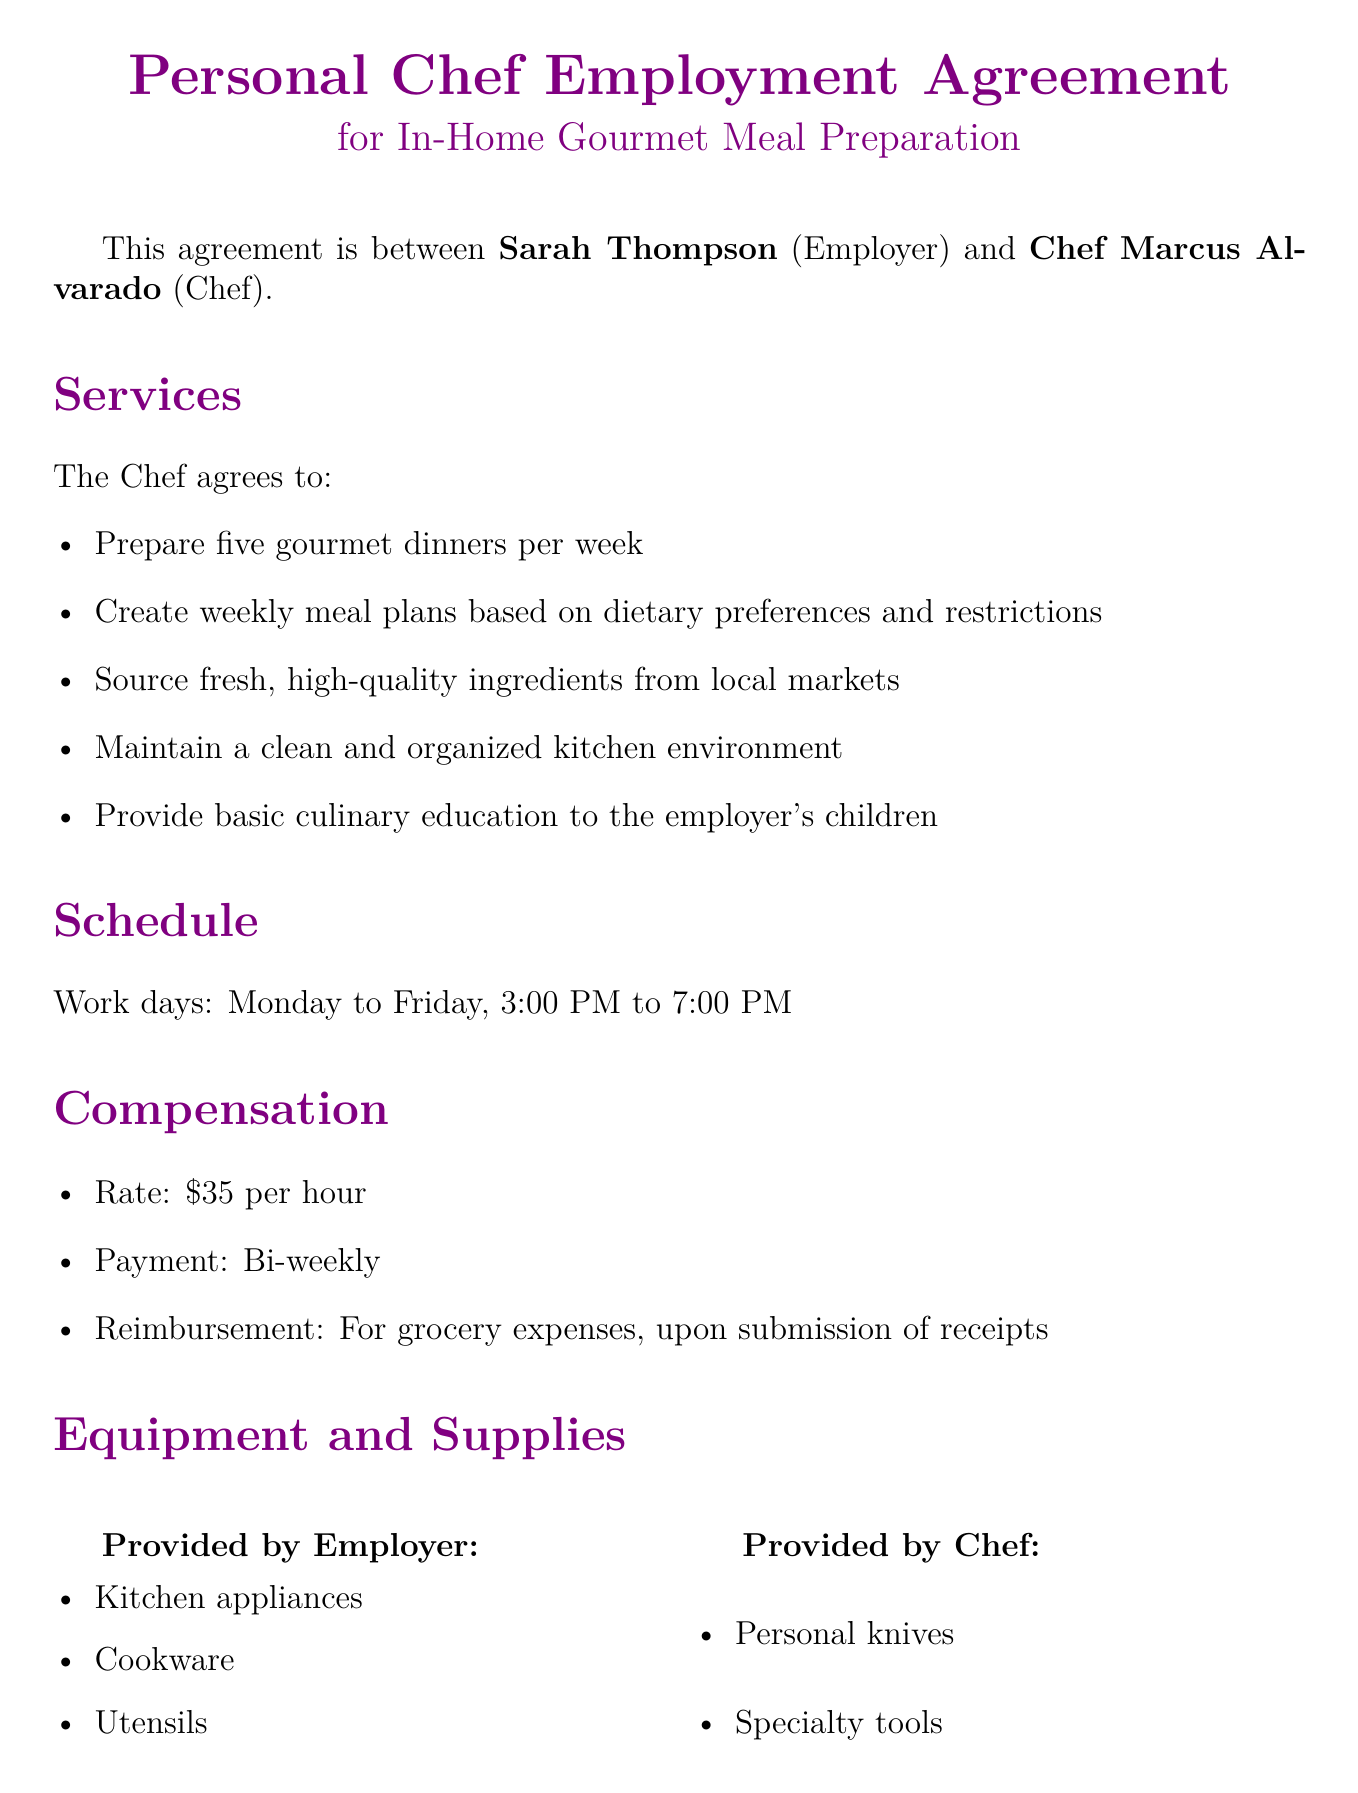What is the chef's hourly rate? The hourly rate is specified in the compensation section of the document, which states it's $35 per hour.
Answer: $35 How many dinners will the chef prepare per week? The services section indicates the chef will prepare five gourmet dinners per week.
Answer: Five What is the notice period for termination? The termination section mentions a two weeks' written notice is required by either party for termination.
Answer: Two weeks What days of the week is the chef working? The schedule section outlines the work days from Monday to Friday.
Answer: Monday to Friday What does the chef need to provide for their work? According to the equipment and supplies section, the chef is responsible for their personal knives and specialty tools.
Answer: Personal knives, specialty tools What type of education will the chef provide? The services section states that the chef will provide basic culinary education to the employer's children.
Answer: Basic culinary education What is the duration of the agreement? The last part of the document specifies that the agreement duration is one year with the option to renew.
Answer: One year What should the chef maintain according to the expectations? The expectations section emphasizes maintaining high standards of food safety and hygiene.
Answer: High standards of food safety and hygiene What is the basis for grocery reimbursement? The compensation section indicates reimbursement for grocery expenses is upon submission of receipts.
Answer: Submission of receipts 